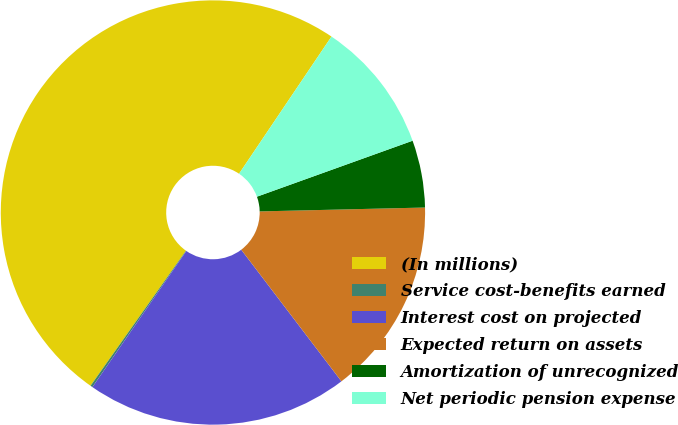Convert chart to OTSL. <chart><loc_0><loc_0><loc_500><loc_500><pie_chart><fcel>(In millions)<fcel>Service cost-benefits earned<fcel>Interest cost on projected<fcel>Expected return on assets<fcel>Amortization of unrecognized<fcel>Net periodic pension expense<nl><fcel>49.65%<fcel>0.17%<fcel>19.97%<fcel>15.02%<fcel>5.12%<fcel>10.07%<nl></chart> 